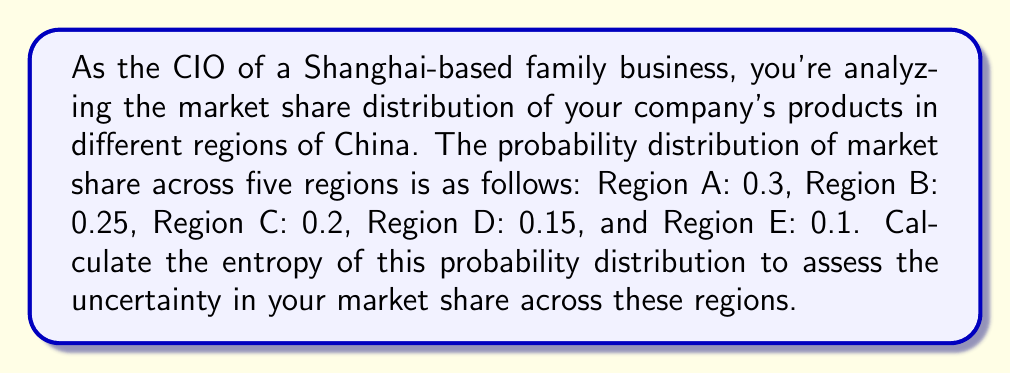Help me with this question. To calculate the entropy of a given probability distribution, we use the formula:

$$H(X) = -\sum_{i=1}^{n} p(x_i) \log_2 p(x_i)$$

Where:
- $H(X)$ is the entropy
- $p(x_i)$ is the probability of each event
- $n$ is the number of possible events

Let's calculate the entropy for each region:

1. Region A: $-0.3 \log_2 0.3$
2. Region B: $-0.25 \log_2 0.25$
3. Region C: $-0.2 \log_2 0.2$
4. Region D: $-0.15 \log_2 0.15$
5. Region E: $-0.1 \log_2 0.1$

Now, let's sum these values:

$$\begin{align*}
H(X) &= (-0.3 \log_2 0.3) + (-0.25 \log_2 0.25) + (-0.2 \log_2 0.2) + (-0.15 \log_2 0.15) + (-0.1 \log_2 0.1) \\
&\approx 0.5211 + 0.5000 + 0.4644 + 0.4101 + 0.3322 \\
&\approx 2.2278 \text{ bits}
\end{align*}$$

The entropy is approximately 2.2278 bits.
Answer: The entropy of the given probability distribution is approximately 2.2278 bits. 